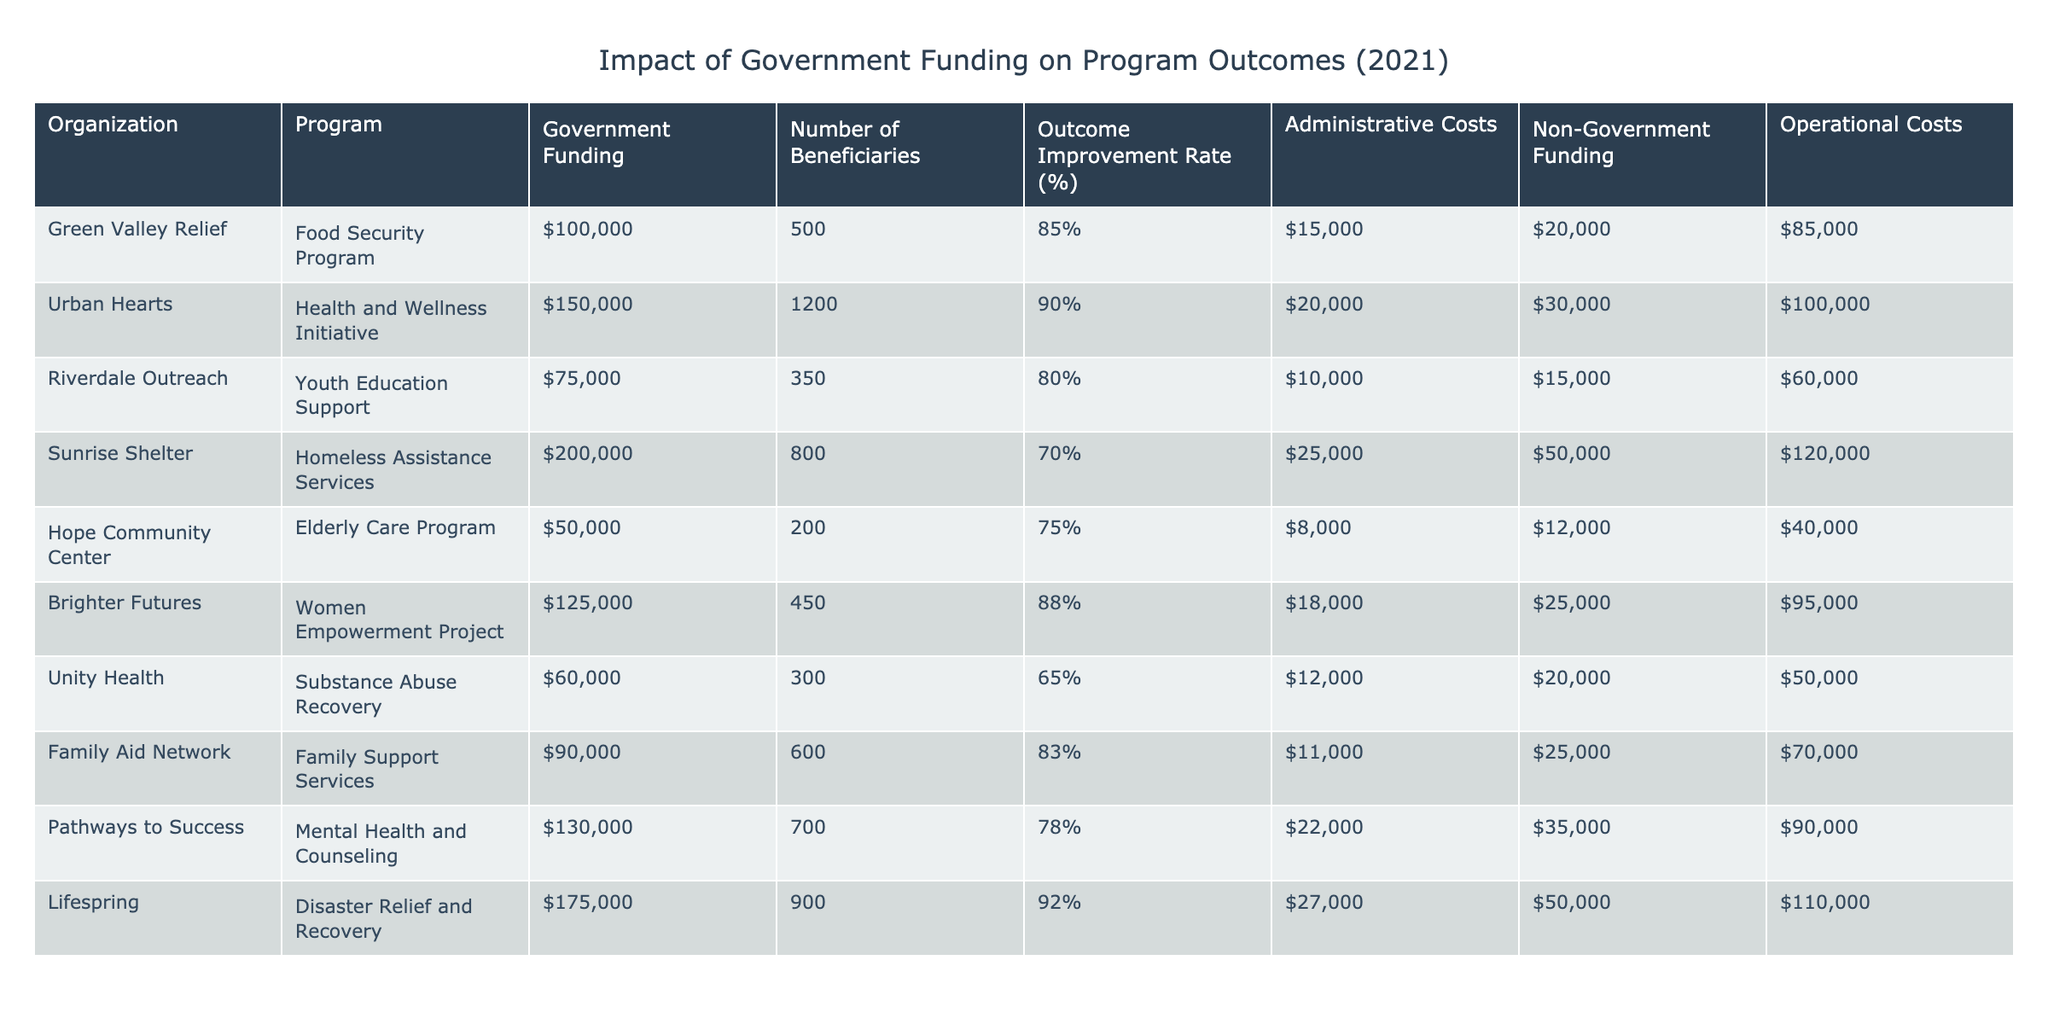What is the total amount of government funding provided to all organizations? To find the total government funding, we add the funding for each organization: 100000 + 150000 + 75000 + 200000 + 50000 + 125000 + 60000 + 90000 + 130000 + 175000 = 1,175,000.
Answer: 1,175,000 Which organization had the highest outcome improvement rate? Looking at the 'Outcome Improvement Rate (%)' column, Urban Hearts has the highest rate at 90%.
Answer: Urban Hearts Did any organization have administrative costs exceeding 25,000? Inspecting the 'Administrative Costs' column, only Sunrise Shelter and Lifespring have costs of 25000 and 27000 respectively, which exceed 25000.
Answer: Yes What is the average number of beneficiaries across all programs? To calculate the average number of beneficiaries, sum up the 'Number of Beneficiaries': 500 + 1200 + 350 + 800 + 200 + 450 + 300 + 600 + 700 + 900 = 5,050. Then, divide by the number of organizations (10): 5050 / 10 = 505.
Answer: 505 Which program had the lowest operational costs? By examining the 'Operational Costs' column, Hope Community Center has the lowest costs at 40000.
Answer: Hope Community Center What percentage of the total government funding went to Urban Hearts? Total government funding is 1,175,000. Urban Hearts received 150,000. The percentage is calculated as (150000 / 1175000) * 100 = 12.77%.
Answer: 12.77% What is the relationship between government funding and outcome improvement rate—do higher funding levels correlate with better outcomes? The data needs to be analyzed collectively; while some programs like Urban Hearts have high funding and high outcomes, others like Unity Health have lower outcomes despite receiving considerable funds. This indicates no clear correlation.
Answer: No clear correlation Is the non-government funding more than the government funding for any organization? Comparing 'Government Funding' and 'Non-Government Funding', we see that only Hope Community Center has non-government funding (12000) that is less than its government funding (50000). All others have more than or equal to government funding.
Answer: No 